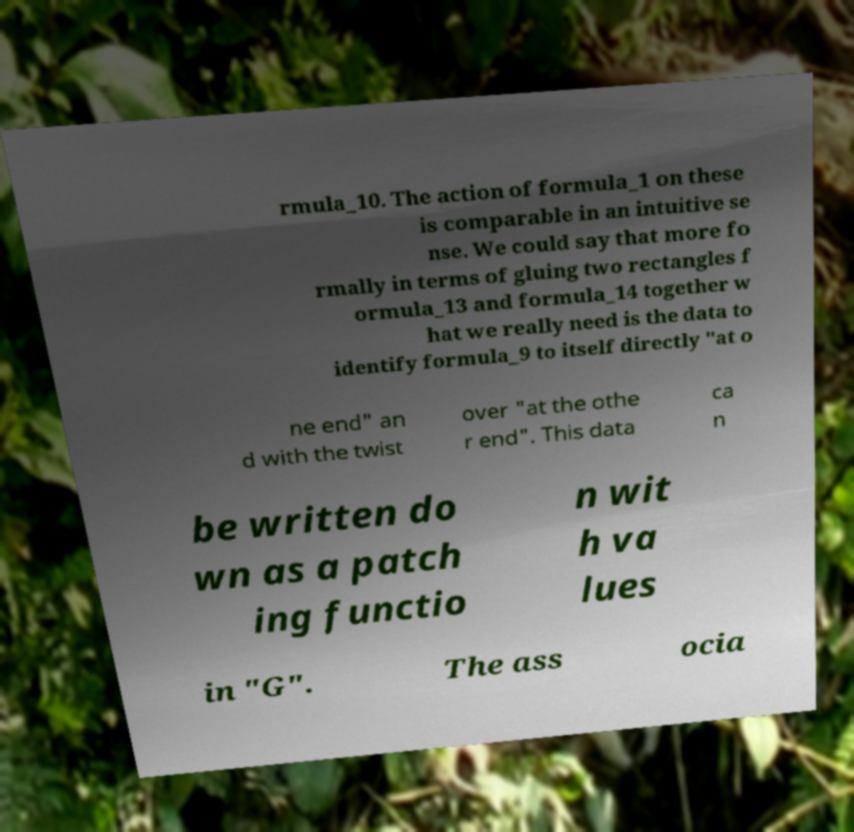Can you read and provide the text displayed in the image?This photo seems to have some interesting text. Can you extract and type it out for me? rmula_10. The action of formula_1 on these is comparable in an intuitive se nse. We could say that more fo rmally in terms of gluing two rectangles f ormula_13 and formula_14 together w hat we really need is the data to identify formula_9 to itself directly "at o ne end" an d with the twist over "at the othe r end". This data ca n be written do wn as a patch ing functio n wit h va lues in "G". The ass ocia 